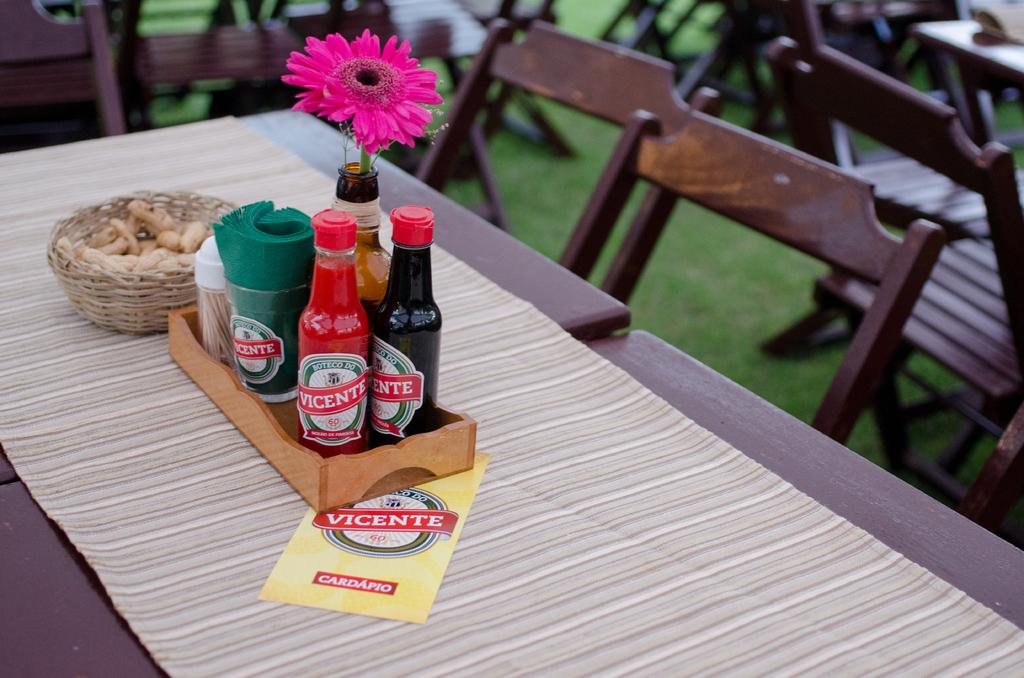<image>
Provide a brief description of the given image. Three different bottles are sitting in a wooden box with the label of vicente on each of them. 